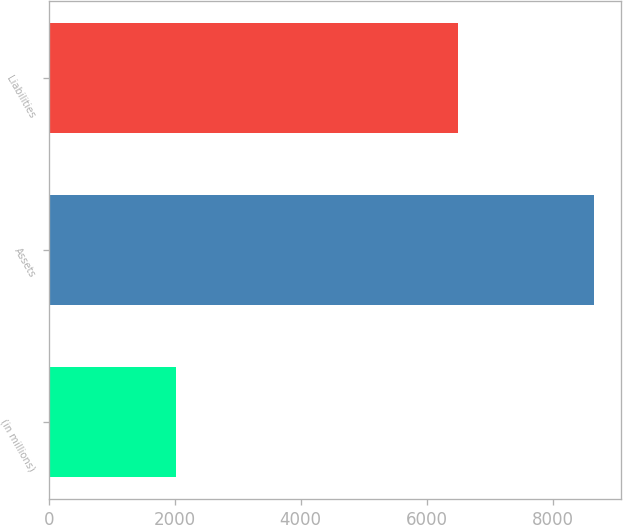Convert chart to OTSL. <chart><loc_0><loc_0><loc_500><loc_500><bar_chart><fcel>(in millions)<fcel>Assets<fcel>Liabilities<nl><fcel>2013<fcel>8649<fcel>6496<nl></chart> 